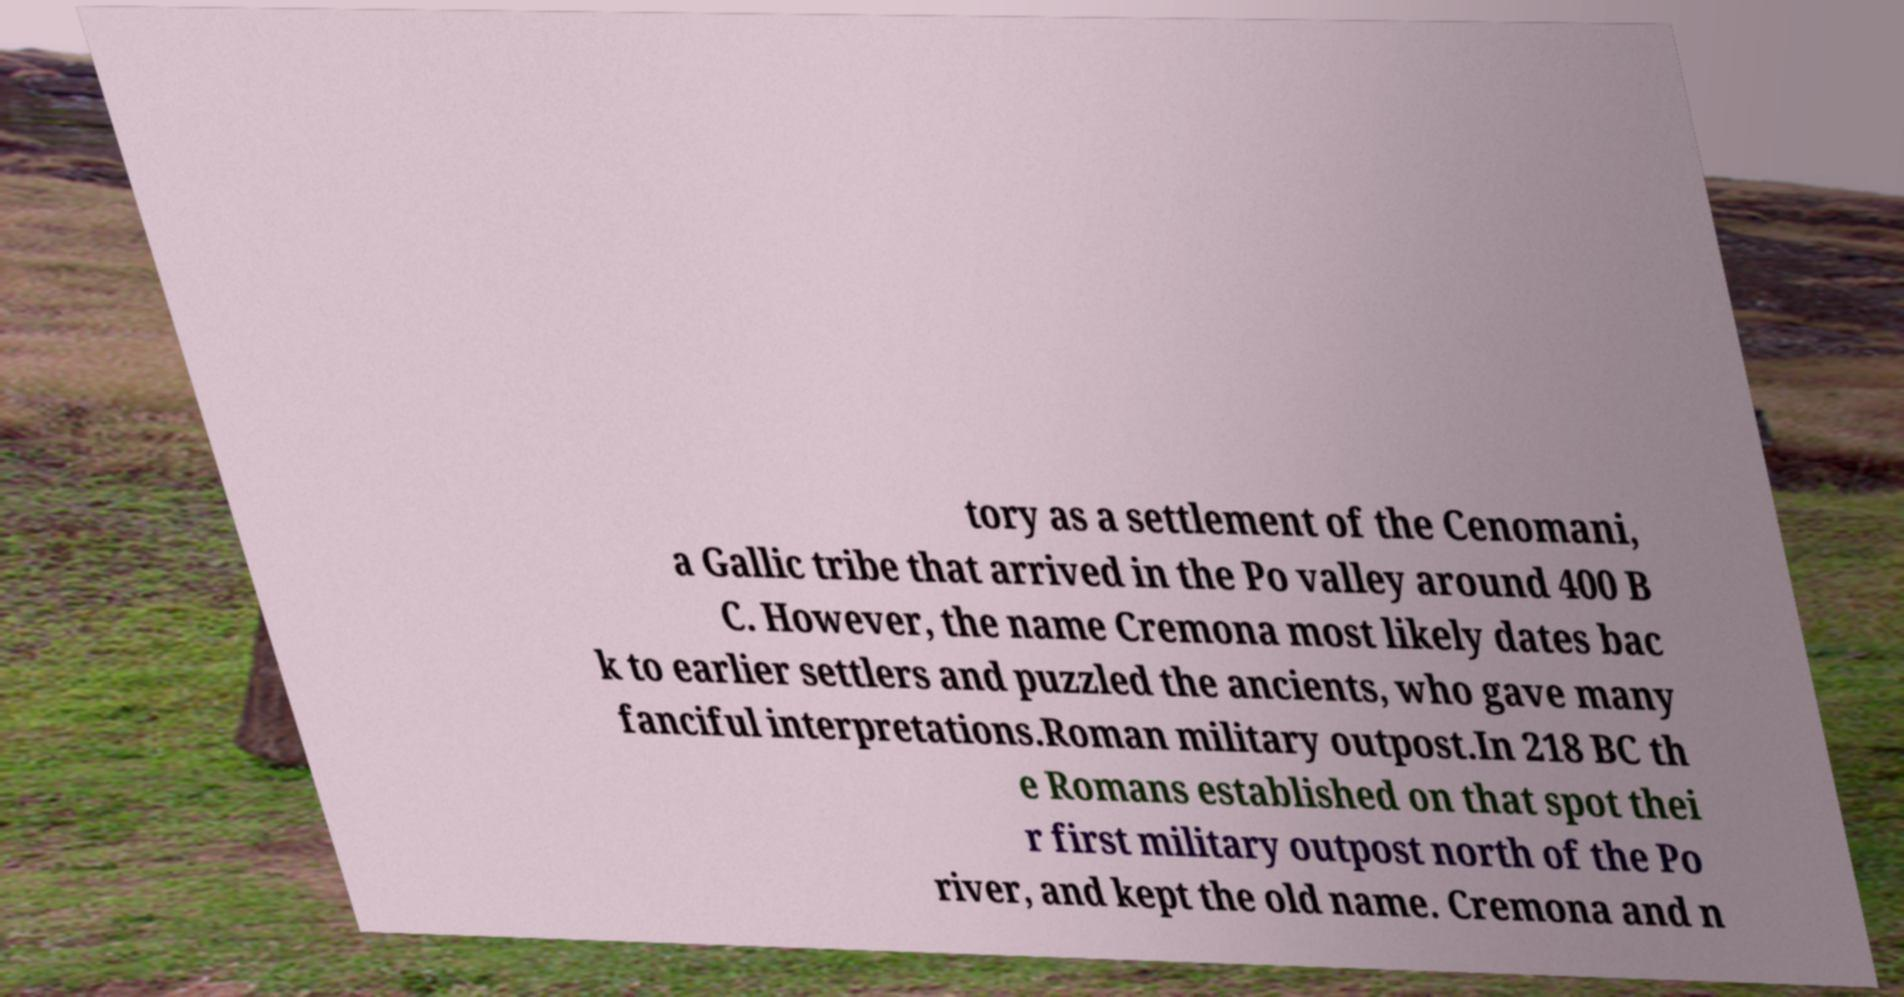Can you accurately transcribe the text from the provided image for me? tory as a settlement of the Cenomani, a Gallic tribe that arrived in the Po valley around 400 B C. However, the name Cremona most likely dates bac k to earlier settlers and puzzled the ancients, who gave many fanciful interpretations.Roman military outpost.In 218 BC th e Romans established on that spot thei r first military outpost north of the Po river, and kept the old name. Cremona and n 